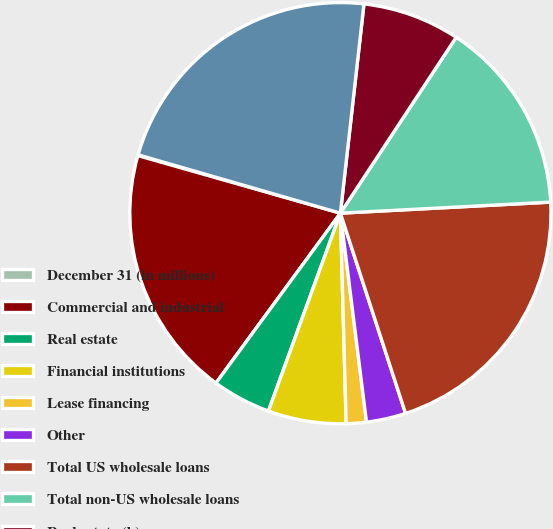Convert chart to OTSL. <chart><loc_0><loc_0><loc_500><loc_500><pie_chart><fcel>December 31 (in millions)<fcel>Commercial and industrial<fcel>Real estate<fcel>Financial institutions<fcel>Lease financing<fcel>Other<fcel>Total US wholesale loans<fcel>Total non-US wholesale loans<fcel>Real estate (b)<fcel>Total wholesale loans<nl><fcel>0.06%<fcel>19.35%<fcel>4.51%<fcel>5.99%<fcel>1.54%<fcel>3.03%<fcel>20.83%<fcel>14.9%<fcel>7.48%<fcel>22.32%<nl></chart> 